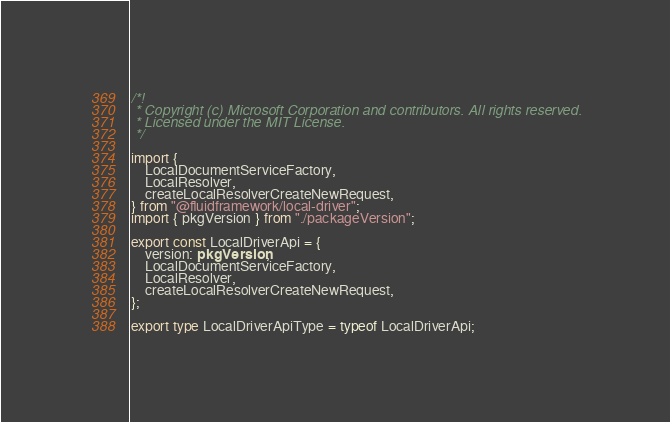<code> <loc_0><loc_0><loc_500><loc_500><_TypeScript_>/*!
 * Copyright (c) Microsoft Corporation and contributors. All rights reserved.
 * Licensed under the MIT License.
 */

import {
    LocalDocumentServiceFactory,
    LocalResolver,
    createLocalResolverCreateNewRequest,
} from "@fluidframework/local-driver";
import { pkgVersion } from "./packageVersion";

export const LocalDriverApi = {
    version: pkgVersion,
    LocalDocumentServiceFactory,
    LocalResolver,
    createLocalResolverCreateNewRequest,
};

export type LocalDriverApiType = typeof LocalDriverApi;
</code> 